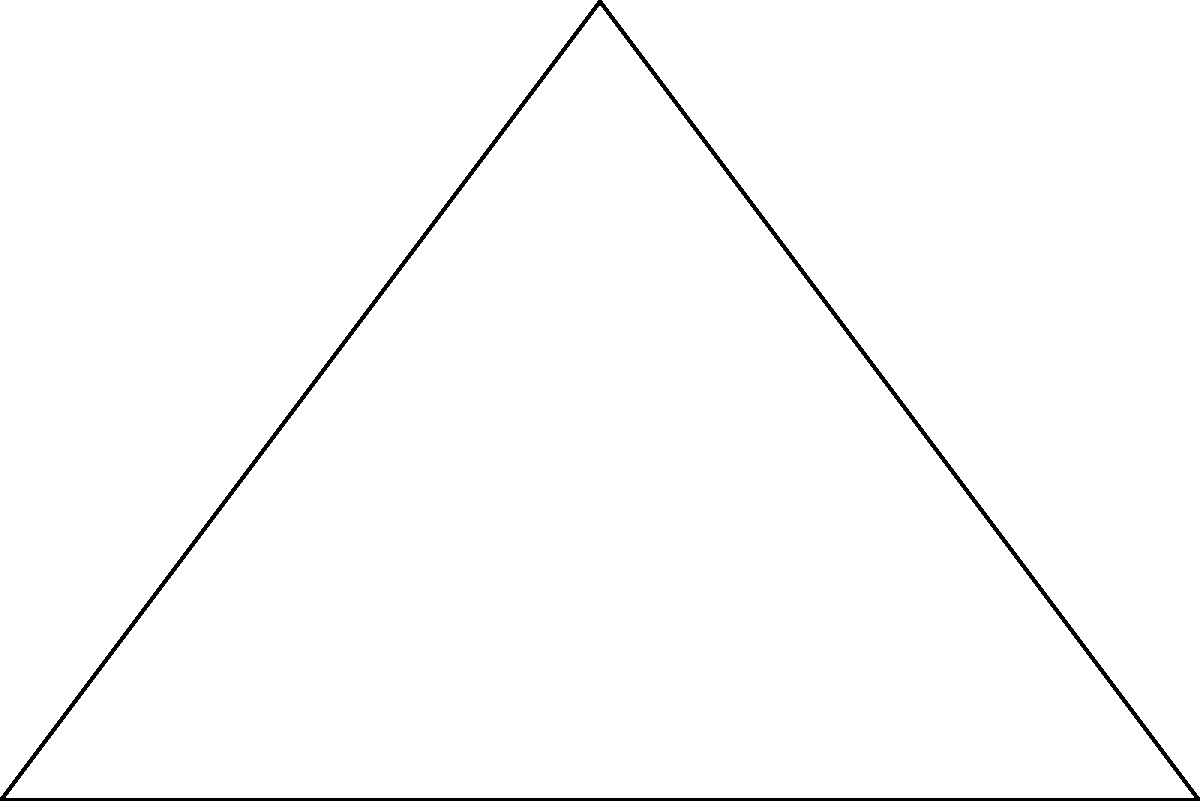As the head of the tech department, you're overseeing a project involving satellite communications. Two satellites, A and B, are in geosynchronous orbit directly above the equator. From a point on Earth's surface, the angle of elevation to Satellite A is 30°, and the distance from this point to Satellite A is 400 km. If the angle between the lines of sight to the two satellites is 60°, what is the distance $d$ between the satellites? Round your answer to the nearest kilometer. Let's approach this step-by-step:

1) First, we can identify this as a triangle problem, where the Earth point forms the right angle, and the two satellites form the other vertices.

2) We're given that the angle of elevation to Satellite A is 30°. This means the angle between the Earth-A line and the line between the satellites is 60° (as the sum of angles in a triangle is 180°).

3) We know the distance from Earth to Satellite A is 400 km. Let's call this side $a$.

4) We can use the law of sines to solve for the distance $d$ between the satellites:

   $$\frac{d}{\sin 30°} = \frac{a}{\sin 60°}$$

5) Substituting the known values:

   $$\frac{d}{\sin 30°} = \frac{400}{\sin 60°}$$

6) Solving for $d$:

   $$d = \frac{400 \sin 30°}{\sin 60°}$$

7) We know that $\sin 30° = \frac{1}{2}$ and $\sin 60° = \frac{\sqrt{3}}{2}$. Substituting these:

   $$d = \frac{400 \cdot \frac{1}{2}}{\frac{\sqrt{3}}{2}} = \frac{200}{\frac{\sqrt{3}}{2}} = \frac{400}{\sqrt{3}}$$

8) Calculating this:

   $$d \approx 230.94 \text{ km}$$

9) Rounding to the nearest kilometer:

   $$d \approx 231 \text{ km}$$
Answer: 231 km 